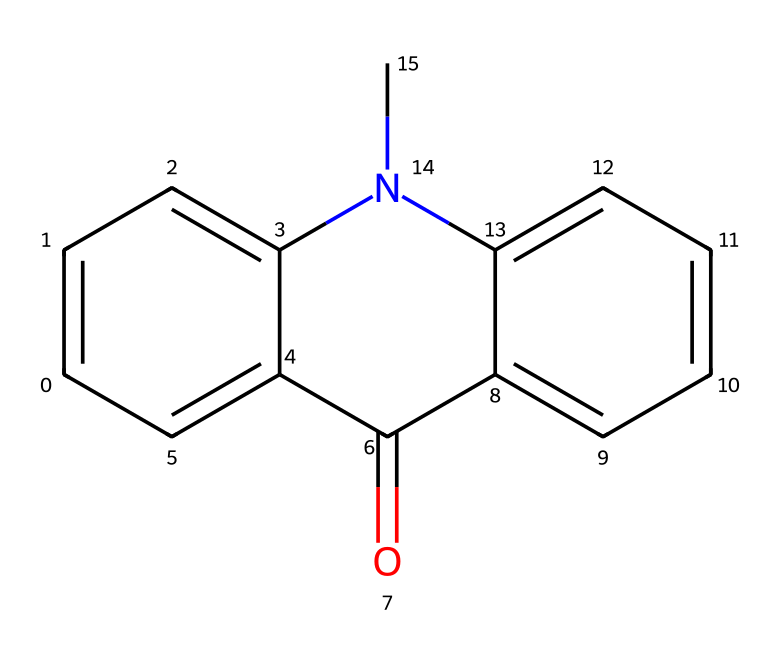What is the molecular formula of this compound? To derive the molecular formula, count the number of carbon (C), hydrogen (H), oxygen (O), and nitrogen (N) atoms present in the SMILES representation. The structure contains 15 carbon atoms, 11 hydrogen atoms, 1 oxygen atom, and 1 nitrogen atom. Therefore, the molecular formula can be written as C15H11NO.
Answer: C15H11NO How many rings are in the structure? By analyzing the chemical structure, observe that there are two distinct rings formed by the carbon atoms. These rings contribute to the overall cyclical structure of the compound and are connected by the nitrogen atom.
Answer: 2 What is the functional group present in this compound? To identify the functional group, look for specific atoms or bonding patterns in the structure. The presence of a carbonyl group (C=O) indicates that this compound includes a ketone functional group.
Answer: ketone Is this compound likely to be polar or nonpolar? Consider the presence of polar functional groups, such as the carbonyl and nitrogen-containing groups, and assess their influence on the overall polarity. Since there are polar bonds and the structure is not symmetrical, the compound is likely to be polar.
Answer: polar What type of bond connects the carbon and nitrogen atoms? Observing the relevant atoms in the SMILES representation, we find that the bond connecting carbon and nitrogen is a single covalent bond, which is typically formed by the sharing of one pair of electrons between the two atoms.
Answer: single covalent bond What role do organic compounds like this one play in OLED technology? Organic compounds such as this one are integral to OLED technology as they serve as emissive materials that emit light when an electric current passes through, thus contributing to the display's functionality and color production.
Answer: emissive materials 